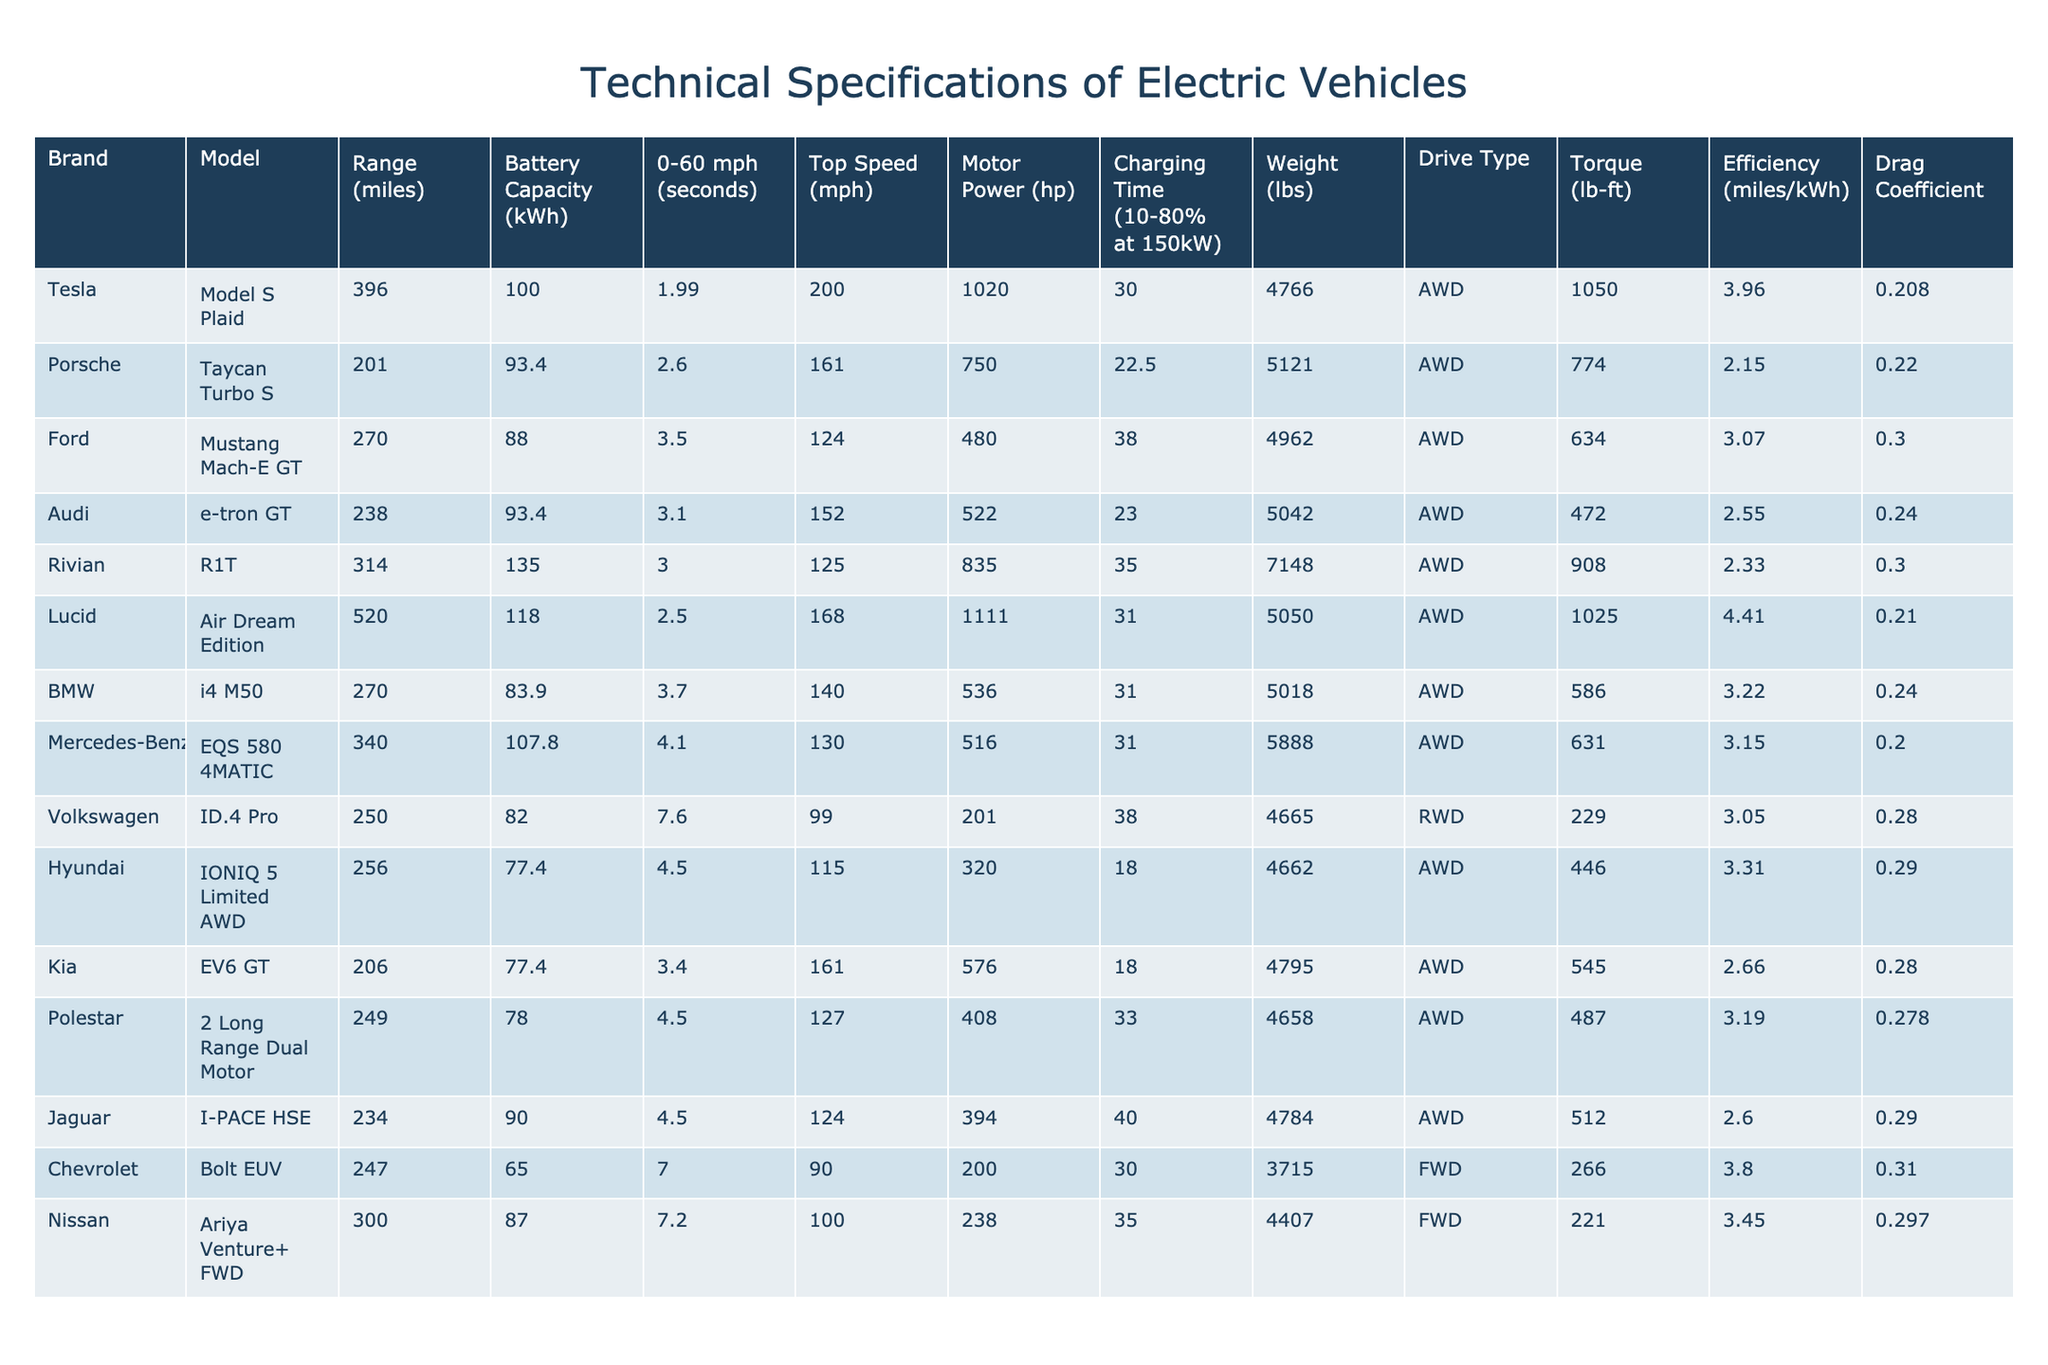What is the range of the Tesla Model S Plaid? The range of the Tesla Model S Plaid is listed in the table under the "Range (miles)" column. It shows 396 miles.
Answer: 396 miles Which vehicle has the highest top speed, and what is that speed? By looking at the "Top Speed (mph)" column, the highest value is 200 mph for the Tesla Model S Plaid.
Answer: Tesla Model S Plaid, 200 mph Is the Ford Mustang Mach-E GT heavier than the Kia EV6 GT? Comparing the "Weight (lbs)" column, the Ford Mustang Mach-E GT is 4962 lbs and the Kia EV6 GT is 4795 lbs, indicating the Mach-E GT is heavier.
Answer: Yes What is the average battery capacity of the vehicles listed in the table? To calculate the average, first sum the battery capacities listed: (100 + 93.4 + 88 + 93.4 + 135 + 118 + 83.9 + 107.8 + 82 + 77.4 + 77.4 + 78 + 90 + 65 + 87) = 1360.6. There are 15 models, so the average is 1360.6 / 15 = 90.73 kWh.
Answer: 90.73 kWh Which vehicle has the most horsepower, and how much is it? The "Motor Power (hp)" column shows the highest value is 1020 hp for the Tesla Model S Plaid.
Answer: Tesla Model S Plaid, 1020 hp Is the efficiency of the Audi e-tron GT greater than that of the Mustang Mach-E GT? The efficiency values from the "Efficiency (miles/kWh)" column show Audi e-tron GT is 2.55 miles/kWh and the Mustang Mach-E GT is 3.07 miles/kWh. Since 2.55 < 3.07, the efficiency of the e-tron GT is not greater.
Answer: No How much more torque does the Rivian R1T have compared to the Chevrolet Bolt EUV? The "Torque (lb-ft)" of Rivian R1T is 908 lb-ft and of Chevrolet Bolt EUV is 266 lb-ft. The difference is 908 - 266 = 642 lb-ft.
Answer: 642 lb-ft Which vehicle has the shortest charging time between 10-80% at 150kW? The data in the "Charging Time (10-80% at 150kW)" column shows that the Hyundai IONIQ 5 Limited AWD has the shortest charging time of 18 minutes.
Answer: Hyundai IONIQ 5 Limited AWD, 18 minutes Which AWD vehicle has the best efficiency? Checking the "Efficiency (miles/kWh)" column, the Lucid Air Dream Edition has an efficiency of 4.41 miles/kWh, which is the highest among AWD vehicles.
Answer: Lucid Air Dream Edition, 4.41 miles/kWh 